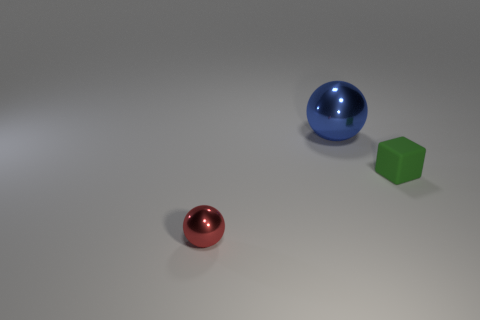Add 1 green blocks. How many objects exist? 4 Subtract all balls. How many objects are left? 1 Subtract all tiny green things. Subtract all green rubber things. How many objects are left? 1 Add 2 tiny green matte cubes. How many tiny green matte cubes are left? 3 Add 1 red balls. How many red balls exist? 2 Subtract 0 purple blocks. How many objects are left? 3 Subtract all gray spheres. Subtract all cyan cubes. How many spheres are left? 2 